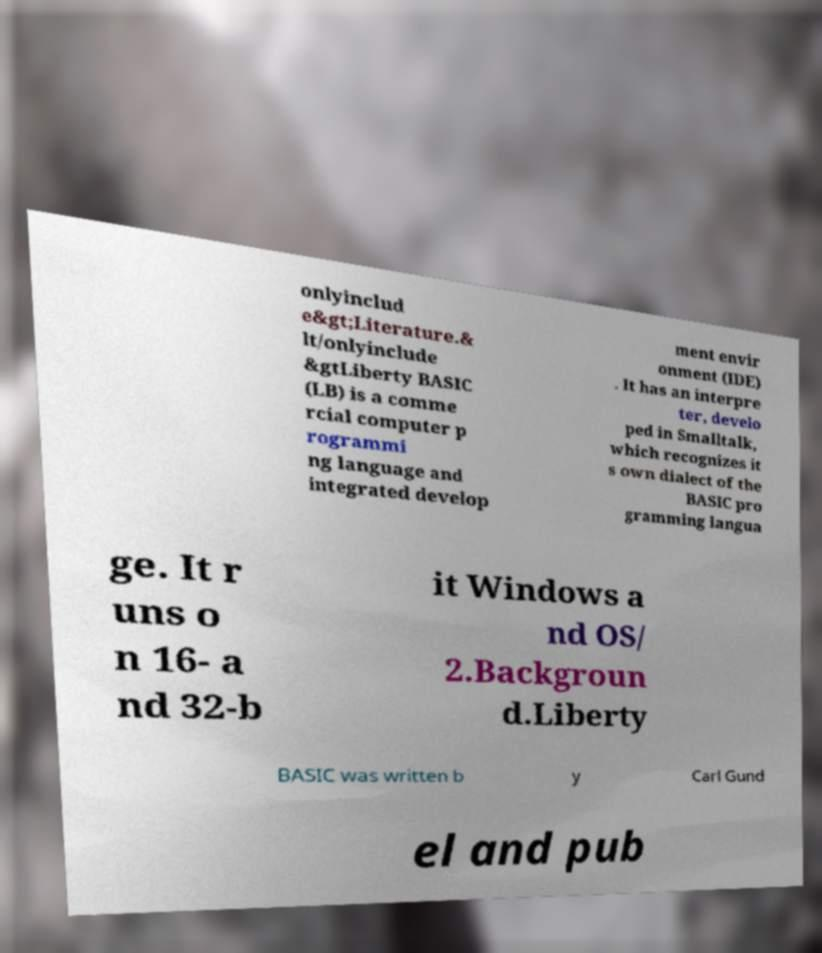Can you read and provide the text displayed in the image?This photo seems to have some interesting text. Can you extract and type it out for me? onlyinclud e&gt;Literature.& lt/onlyinclude &gtLiberty BASIC (LB) is a comme rcial computer p rogrammi ng language and integrated develop ment envir onment (IDE) . It has an interpre ter, develo ped in Smalltalk, which recognizes it s own dialect of the BASIC pro gramming langua ge. It r uns o n 16- a nd 32-b it Windows a nd OS/ 2.Backgroun d.Liberty BASIC was written b y Carl Gund el and pub 